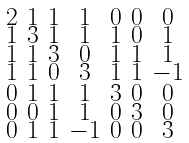Convert formula to latex. <formula><loc_0><loc_0><loc_500><loc_500>\begin{smallmatrix} 2 & 1 & 1 & 1 & 0 & 0 & 0 \\ 1 & 3 & 1 & 1 & 1 & 0 & 1 \\ 1 & 1 & 3 & 0 & 1 & 1 & 1 \\ 1 & 1 & 0 & 3 & 1 & 1 & - 1 \\ 0 & 1 & 1 & 1 & 3 & 0 & 0 \\ 0 & 0 & 1 & 1 & 0 & 3 & 0 \\ 0 & 1 & 1 & - 1 & 0 & 0 & 3 \end{smallmatrix}</formula> 